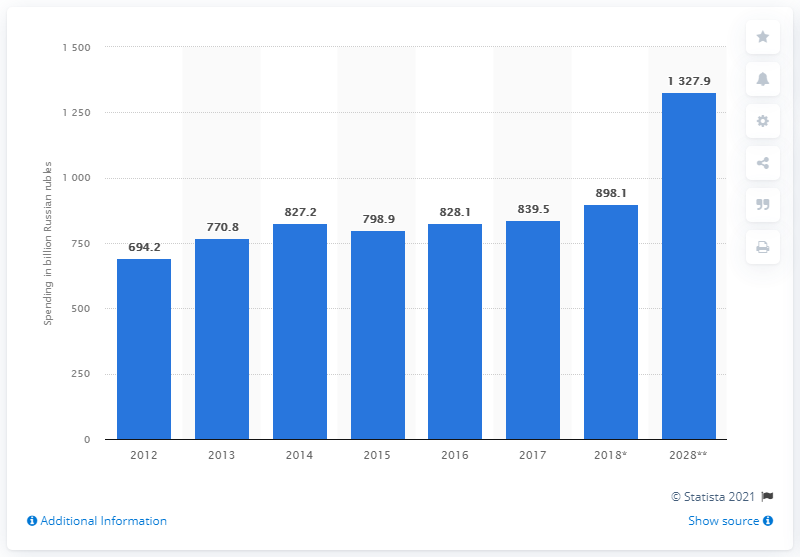Mention a couple of crucial points in this snapshot. In 2017, international visitors spent a total of 839.5 Russian rubles while visiting Russia. 